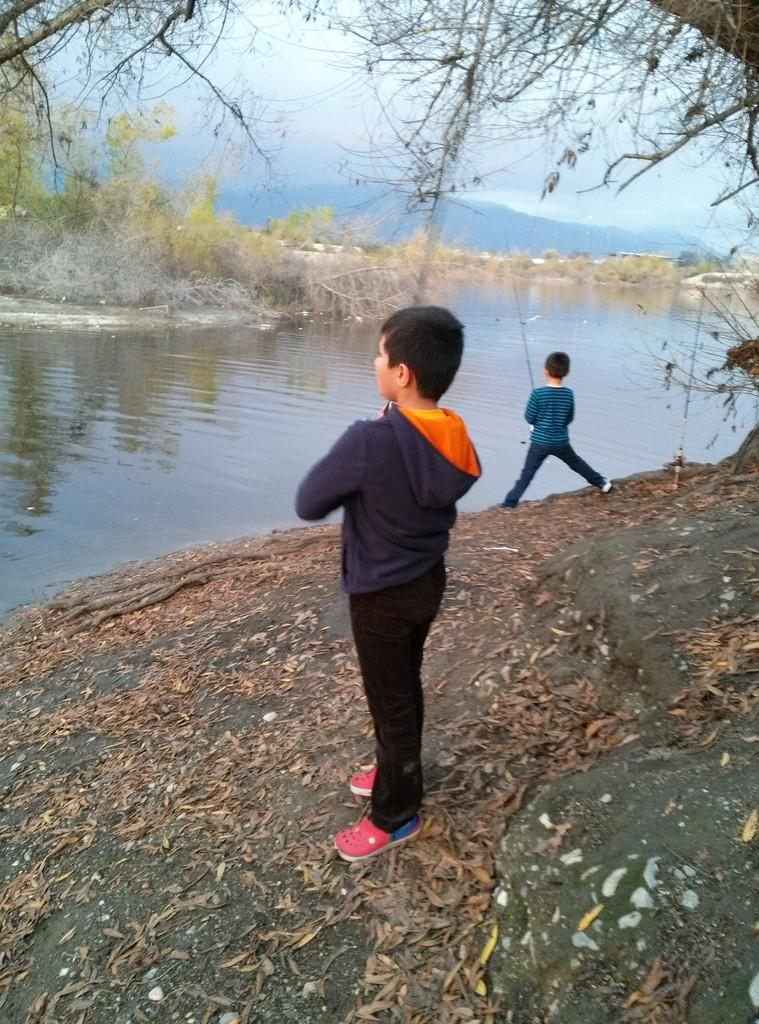How many children are present in the image? There are two children in the image. What activity are the children engaged in? The children are fishing. What type of environment is depicted in the image? There is water in the image, suggesting a waterfront or aquatic setting. What type of grape can be seen growing near the water in the image? There are no grapes present in the image; it features two children fishing in a water-based setting. 